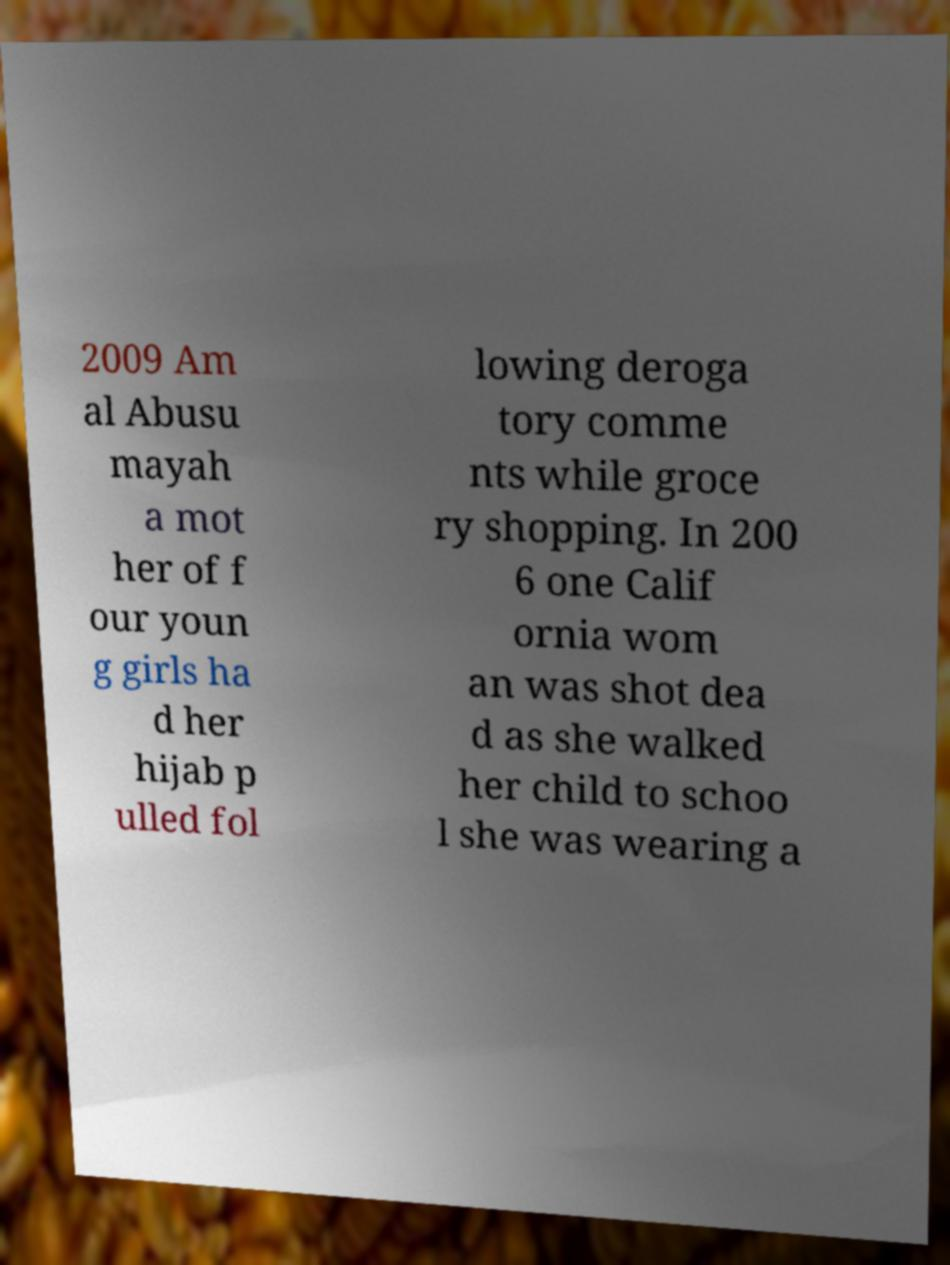What messages or text are displayed in this image? I need them in a readable, typed format. 2009 Am al Abusu mayah a mot her of f our youn g girls ha d her hijab p ulled fol lowing deroga tory comme nts while groce ry shopping. In 200 6 one Calif ornia wom an was shot dea d as she walked her child to schoo l she was wearing a 